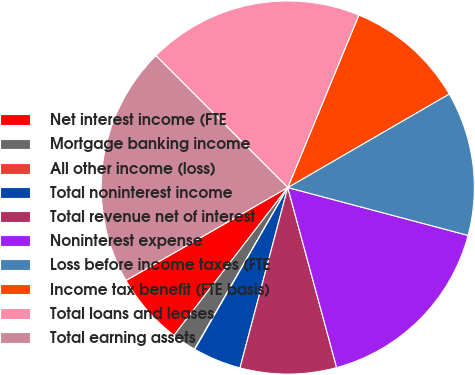Convert chart to OTSL. <chart><loc_0><loc_0><loc_500><loc_500><pie_chart><fcel>Net interest income (FTE<fcel>Mortgage banking income<fcel>All other income (loss)<fcel>Total noninterest income<fcel>Total revenue net of interest<fcel>Noninterest expense<fcel>Loss before income taxes (FTE<fcel>Income tax benefit (FTE basis)<fcel>Total loans and leases<fcel>Total earning assets<nl><fcel>6.26%<fcel>2.11%<fcel>0.03%<fcel>4.18%<fcel>8.34%<fcel>16.65%<fcel>12.49%<fcel>10.42%<fcel>18.72%<fcel>20.8%<nl></chart> 